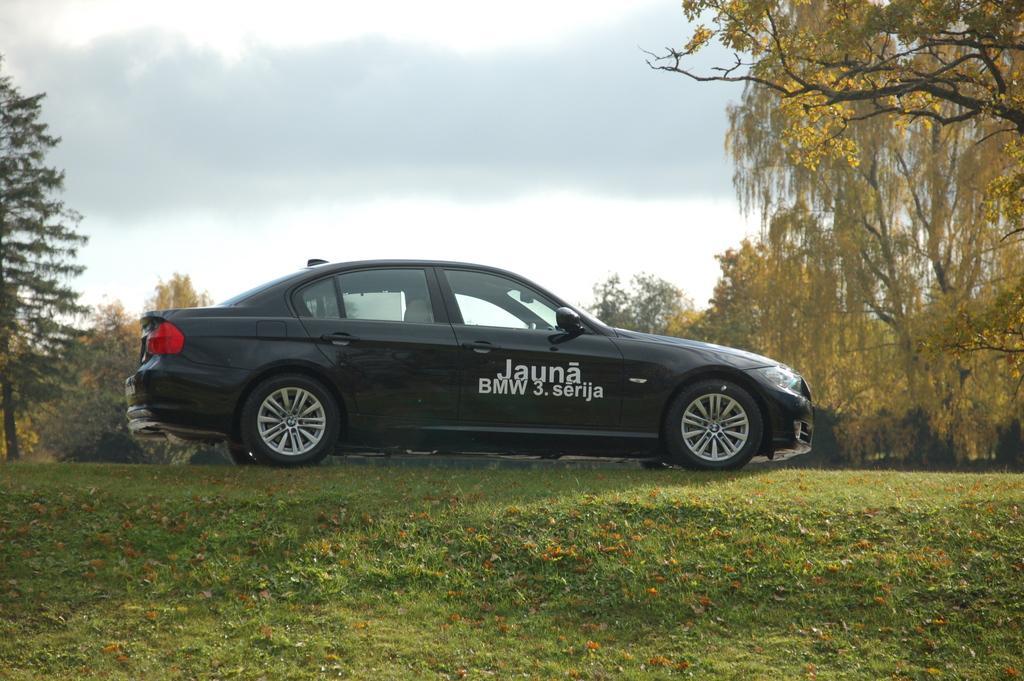Please provide a concise description of this image. In this image in the front there's grass on the ground and in the center there are cars. In the background there are trees and the sky is cloudy and there is some text written on the car which is black in colour. 